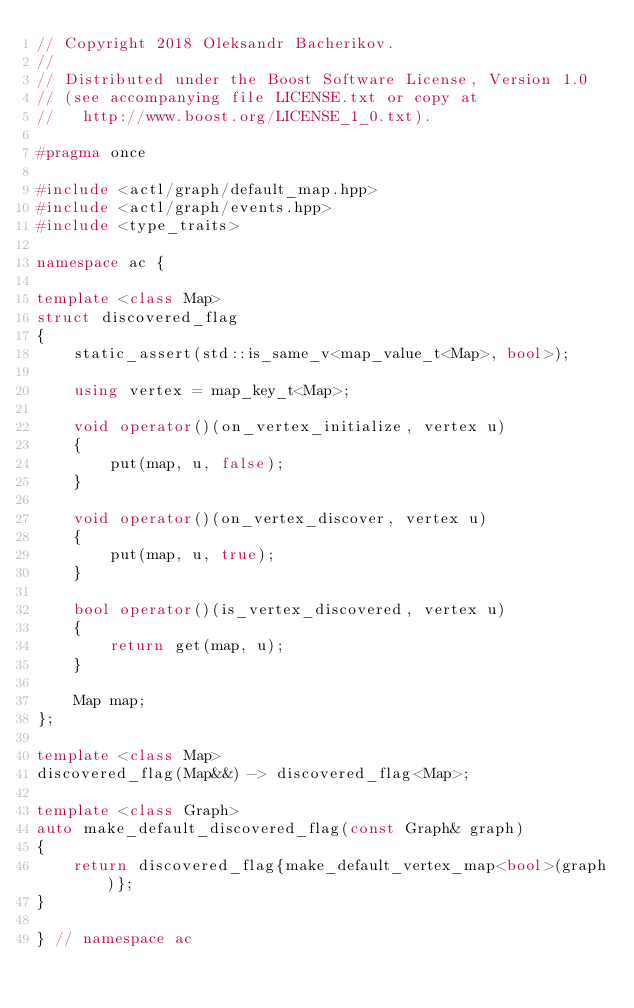<code> <loc_0><loc_0><loc_500><loc_500><_C++_>// Copyright 2018 Oleksandr Bacherikov.
//
// Distributed under the Boost Software License, Version 1.0
// (see accompanying file LICENSE.txt or copy at
//   http://www.boost.org/LICENSE_1_0.txt).

#pragma once

#include <actl/graph/default_map.hpp>
#include <actl/graph/events.hpp>
#include <type_traits>

namespace ac {

template <class Map>
struct discovered_flag
{
    static_assert(std::is_same_v<map_value_t<Map>, bool>);

    using vertex = map_key_t<Map>;

    void operator()(on_vertex_initialize, vertex u)
    {
        put(map, u, false);
    }

    void operator()(on_vertex_discover, vertex u)
    {
        put(map, u, true);
    }

    bool operator()(is_vertex_discovered, vertex u)
    {
        return get(map, u);
    }

    Map map;
};

template <class Map>
discovered_flag(Map&&) -> discovered_flag<Map>;

template <class Graph>
auto make_default_discovered_flag(const Graph& graph)
{
    return discovered_flag{make_default_vertex_map<bool>(graph)};
}

} // namespace ac
</code> 